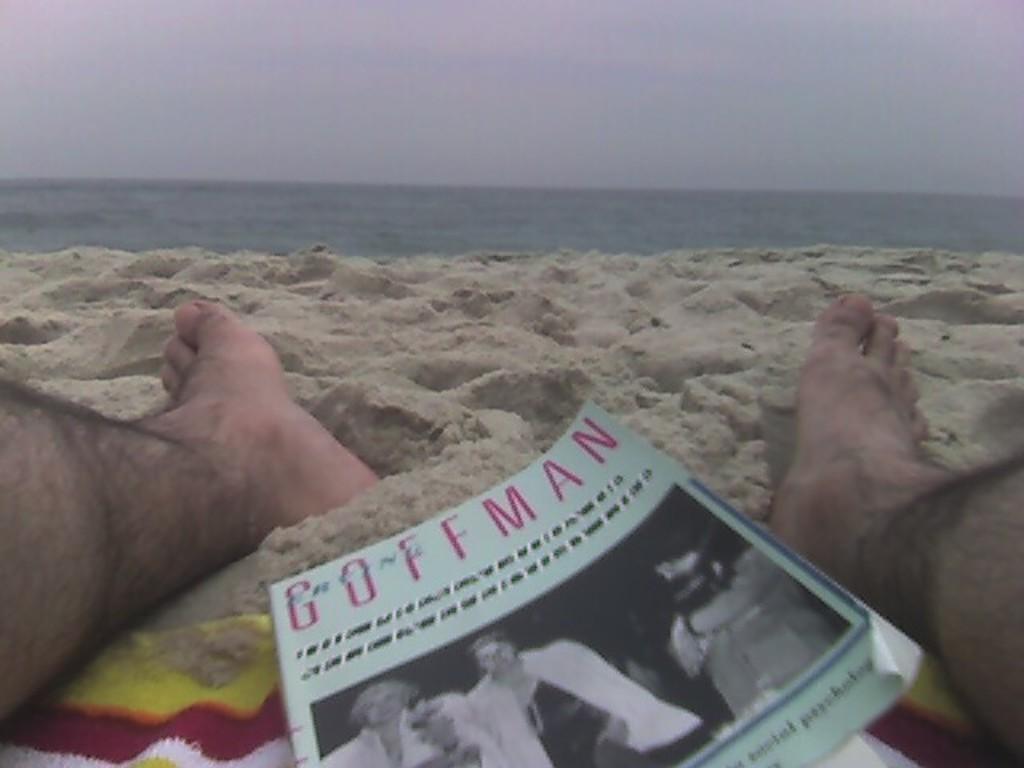Describe this image in one or two sentences. This is the picture of a sea. In this image there is a person sitting on the sand and there is a book on the sand. In the book there are two persons standing. At the back there is water. At the top there is sky. At the bottom there is water. 